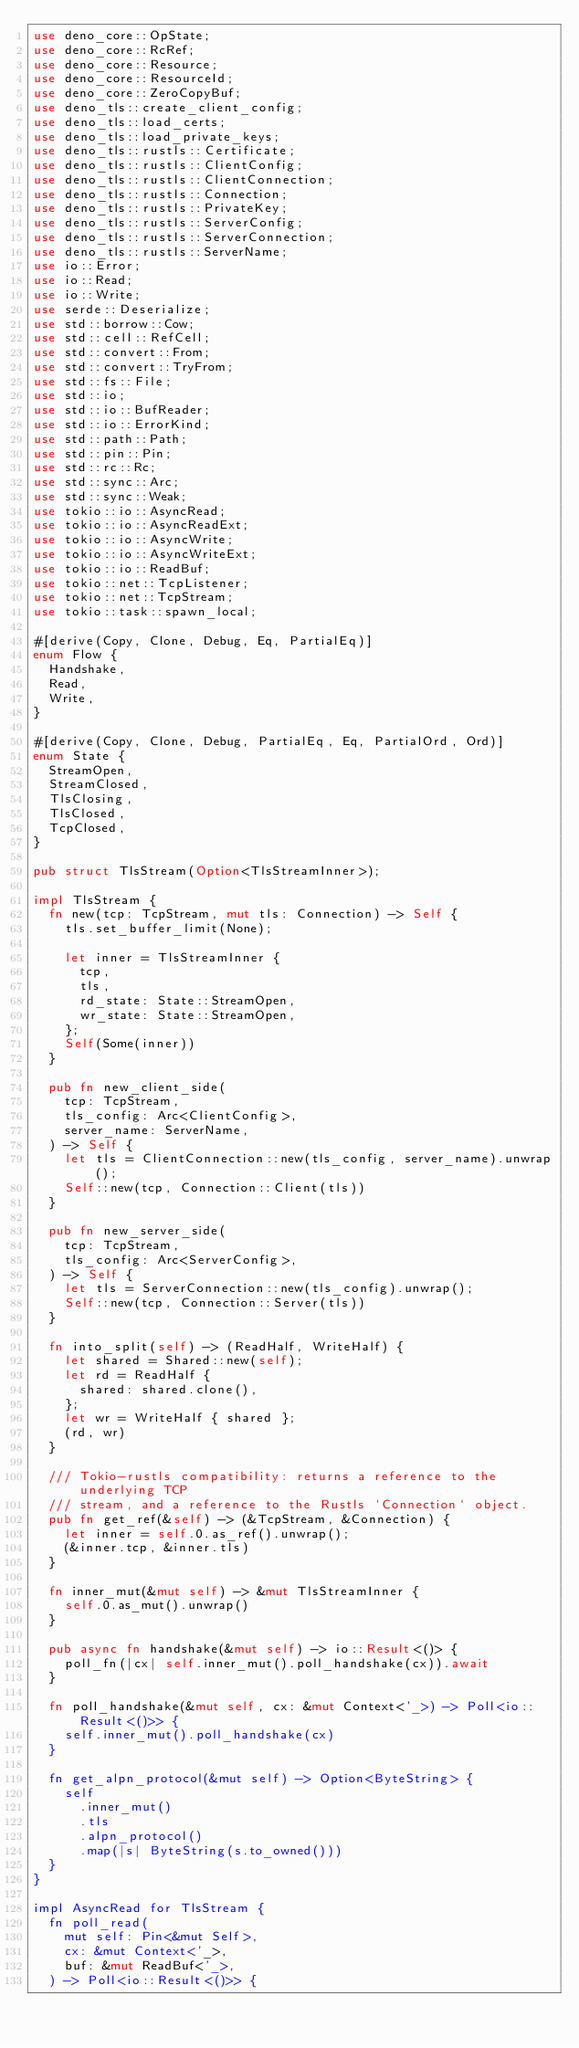Convert code to text. <code><loc_0><loc_0><loc_500><loc_500><_Rust_>use deno_core::OpState;
use deno_core::RcRef;
use deno_core::Resource;
use deno_core::ResourceId;
use deno_core::ZeroCopyBuf;
use deno_tls::create_client_config;
use deno_tls::load_certs;
use deno_tls::load_private_keys;
use deno_tls::rustls::Certificate;
use deno_tls::rustls::ClientConfig;
use deno_tls::rustls::ClientConnection;
use deno_tls::rustls::Connection;
use deno_tls::rustls::PrivateKey;
use deno_tls::rustls::ServerConfig;
use deno_tls::rustls::ServerConnection;
use deno_tls::rustls::ServerName;
use io::Error;
use io::Read;
use io::Write;
use serde::Deserialize;
use std::borrow::Cow;
use std::cell::RefCell;
use std::convert::From;
use std::convert::TryFrom;
use std::fs::File;
use std::io;
use std::io::BufReader;
use std::io::ErrorKind;
use std::path::Path;
use std::pin::Pin;
use std::rc::Rc;
use std::sync::Arc;
use std::sync::Weak;
use tokio::io::AsyncRead;
use tokio::io::AsyncReadExt;
use tokio::io::AsyncWrite;
use tokio::io::AsyncWriteExt;
use tokio::io::ReadBuf;
use tokio::net::TcpListener;
use tokio::net::TcpStream;
use tokio::task::spawn_local;

#[derive(Copy, Clone, Debug, Eq, PartialEq)]
enum Flow {
  Handshake,
  Read,
  Write,
}

#[derive(Copy, Clone, Debug, PartialEq, Eq, PartialOrd, Ord)]
enum State {
  StreamOpen,
  StreamClosed,
  TlsClosing,
  TlsClosed,
  TcpClosed,
}

pub struct TlsStream(Option<TlsStreamInner>);

impl TlsStream {
  fn new(tcp: TcpStream, mut tls: Connection) -> Self {
    tls.set_buffer_limit(None);

    let inner = TlsStreamInner {
      tcp,
      tls,
      rd_state: State::StreamOpen,
      wr_state: State::StreamOpen,
    };
    Self(Some(inner))
  }

  pub fn new_client_side(
    tcp: TcpStream,
    tls_config: Arc<ClientConfig>,
    server_name: ServerName,
  ) -> Self {
    let tls = ClientConnection::new(tls_config, server_name).unwrap();
    Self::new(tcp, Connection::Client(tls))
  }

  pub fn new_server_side(
    tcp: TcpStream,
    tls_config: Arc<ServerConfig>,
  ) -> Self {
    let tls = ServerConnection::new(tls_config).unwrap();
    Self::new(tcp, Connection::Server(tls))
  }

  fn into_split(self) -> (ReadHalf, WriteHalf) {
    let shared = Shared::new(self);
    let rd = ReadHalf {
      shared: shared.clone(),
    };
    let wr = WriteHalf { shared };
    (rd, wr)
  }

  /// Tokio-rustls compatibility: returns a reference to the underlying TCP
  /// stream, and a reference to the Rustls `Connection` object.
  pub fn get_ref(&self) -> (&TcpStream, &Connection) {
    let inner = self.0.as_ref().unwrap();
    (&inner.tcp, &inner.tls)
  }

  fn inner_mut(&mut self) -> &mut TlsStreamInner {
    self.0.as_mut().unwrap()
  }

  pub async fn handshake(&mut self) -> io::Result<()> {
    poll_fn(|cx| self.inner_mut().poll_handshake(cx)).await
  }

  fn poll_handshake(&mut self, cx: &mut Context<'_>) -> Poll<io::Result<()>> {
    self.inner_mut().poll_handshake(cx)
  }

  fn get_alpn_protocol(&mut self) -> Option<ByteString> {
    self
      .inner_mut()
      .tls
      .alpn_protocol()
      .map(|s| ByteString(s.to_owned()))
  }
}

impl AsyncRead for TlsStream {
  fn poll_read(
    mut self: Pin<&mut Self>,
    cx: &mut Context<'_>,
    buf: &mut ReadBuf<'_>,
  ) -> Poll<io::Result<()>> {</code> 